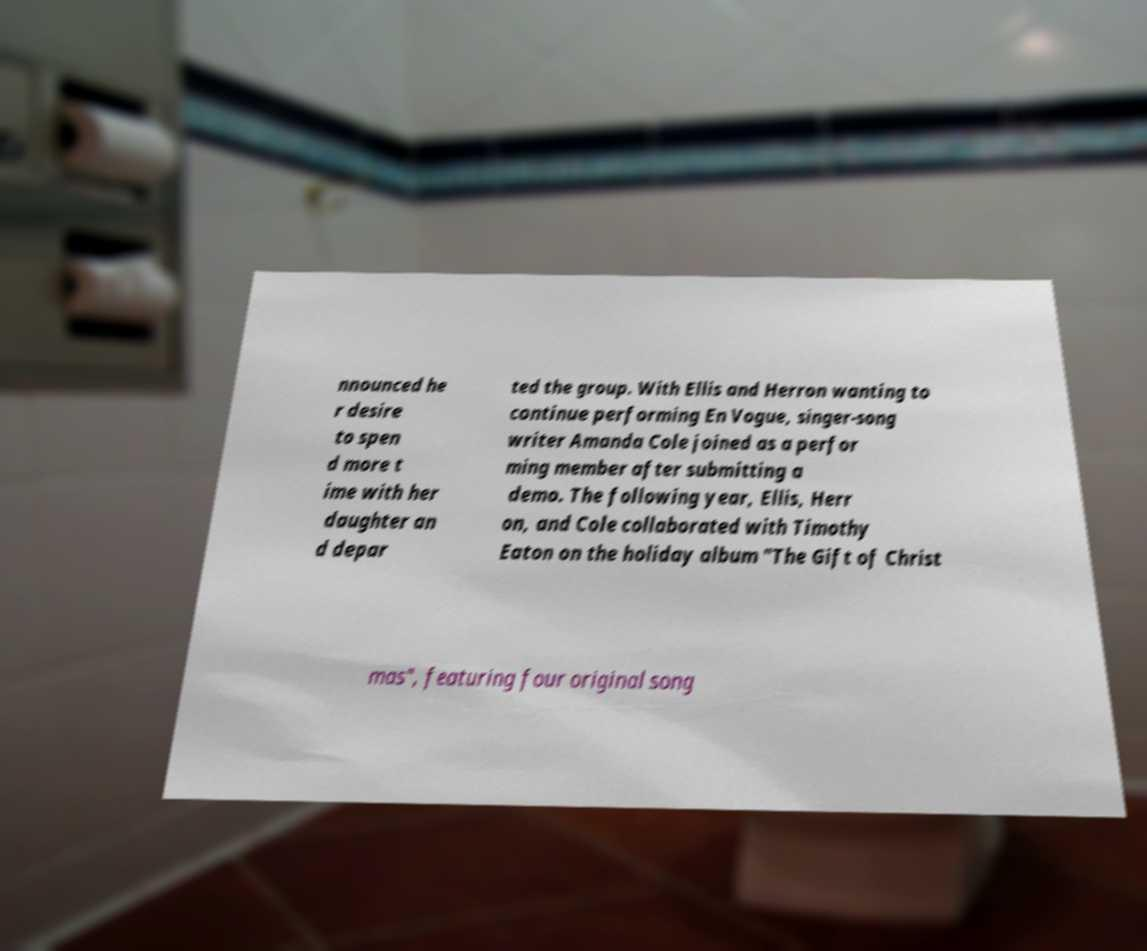What messages or text are displayed in this image? I need them in a readable, typed format. nnounced he r desire to spen d more t ime with her daughter an d depar ted the group. With Ellis and Herron wanting to continue performing En Vogue, singer-song writer Amanda Cole joined as a perfor ming member after submitting a demo. The following year, Ellis, Herr on, and Cole collaborated with Timothy Eaton on the holiday album "The Gift of Christ mas", featuring four original song 